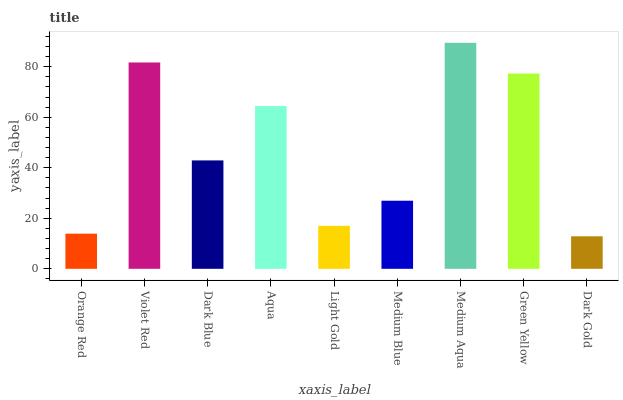Is Dark Gold the minimum?
Answer yes or no. Yes. Is Medium Aqua the maximum?
Answer yes or no. Yes. Is Violet Red the minimum?
Answer yes or no. No. Is Violet Red the maximum?
Answer yes or no. No. Is Violet Red greater than Orange Red?
Answer yes or no. Yes. Is Orange Red less than Violet Red?
Answer yes or no. Yes. Is Orange Red greater than Violet Red?
Answer yes or no. No. Is Violet Red less than Orange Red?
Answer yes or no. No. Is Dark Blue the high median?
Answer yes or no. Yes. Is Dark Blue the low median?
Answer yes or no. Yes. Is Violet Red the high median?
Answer yes or no. No. Is Violet Red the low median?
Answer yes or no. No. 